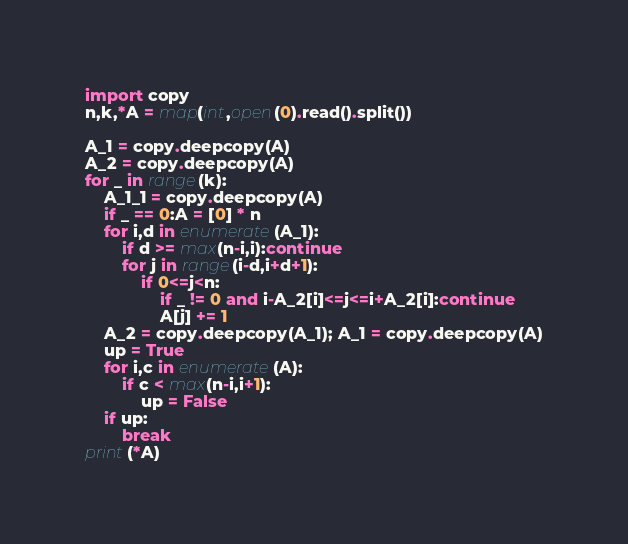Convert code to text. <code><loc_0><loc_0><loc_500><loc_500><_Python_>import copy
n,k,*A = map(int,open(0).read().split())

A_1 = copy.deepcopy(A)
A_2 = copy.deepcopy(A)
for _ in range(k):
    A_1_1 = copy.deepcopy(A)
    if _ == 0:A = [0] * n
    for i,d in enumerate(A_1):
        if d >= max(n-i,i):continue
        for j in range(i-d,i+d+1):
            if 0<=j<n:
                if _ != 0 and i-A_2[i]<=j<=i+A_2[i]:continue
                A[j] += 1
    A_2 = copy.deepcopy(A_1); A_1 = copy.deepcopy(A)
    up = True
    for i,c in enumerate(A):
        if c < max(n-i,i+1):
            up = False          
    if up:
        break
print(*A)
</code> 